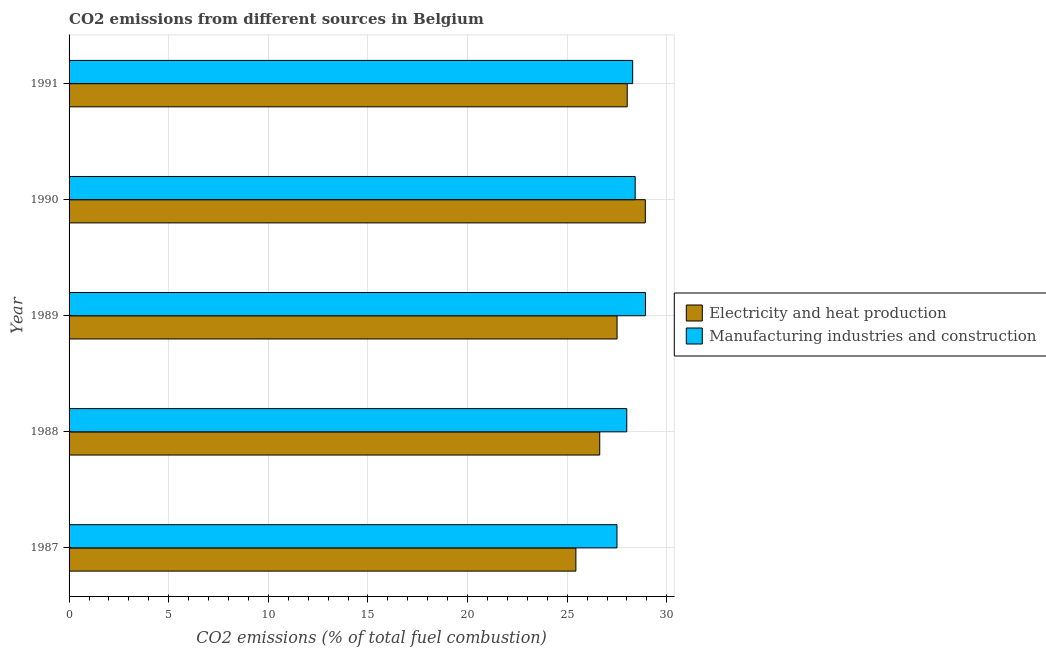How many groups of bars are there?
Keep it short and to the point. 5. Are the number of bars per tick equal to the number of legend labels?
Your response must be concise. Yes. Are the number of bars on each tick of the Y-axis equal?
Provide a succinct answer. Yes. How many bars are there on the 2nd tick from the top?
Give a very brief answer. 2. What is the co2 emissions due to manufacturing industries in 1991?
Ensure brevity in your answer.  28.29. Across all years, what is the maximum co2 emissions due to electricity and heat production?
Make the answer very short. 28.92. Across all years, what is the minimum co2 emissions due to manufacturing industries?
Your answer should be very brief. 27.5. In which year was the co2 emissions due to electricity and heat production maximum?
Your answer should be very brief. 1990. What is the total co2 emissions due to electricity and heat production in the graph?
Ensure brevity in your answer.  136.5. What is the difference between the co2 emissions due to electricity and heat production in 1990 and that in 1991?
Ensure brevity in your answer.  0.91. What is the difference between the co2 emissions due to manufacturing industries in 1987 and the co2 emissions due to electricity and heat production in 1989?
Offer a terse response. -0. What is the average co2 emissions due to manufacturing industries per year?
Your answer should be compact. 28.22. In the year 1988, what is the difference between the co2 emissions due to manufacturing industries and co2 emissions due to electricity and heat production?
Keep it short and to the point. 1.36. In how many years, is the co2 emissions due to manufacturing industries greater than 4 %?
Make the answer very short. 5. What is the ratio of the co2 emissions due to electricity and heat production in 1987 to that in 1991?
Keep it short and to the point. 0.91. Is the difference between the co2 emissions due to manufacturing industries in 1987 and 1990 greater than the difference between the co2 emissions due to electricity and heat production in 1987 and 1990?
Provide a succinct answer. Yes. What is the difference between the highest and the second highest co2 emissions due to manufacturing industries?
Offer a terse response. 0.52. What is the difference between the highest and the lowest co2 emissions due to electricity and heat production?
Ensure brevity in your answer.  3.49. What does the 2nd bar from the top in 1989 represents?
Offer a terse response. Electricity and heat production. What does the 1st bar from the bottom in 1991 represents?
Your answer should be compact. Electricity and heat production. How many bars are there?
Your answer should be compact. 10. Does the graph contain any zero values?
Offer a terse response. No. Where does the legend appear in the graph?
Keep it short and to the point. Center right. How many legend labels are there?
Provide a short and direct response. 2. How are the legend labels stacked?
Provide a short and direct response. Vertical. What is the title of the graph?
Provide a succinct answer. CO2 emissions from different sources in Belgium. Does "% of gross capital formation" appear as one of the legend labels in the graph?
Offer a very short reply. No. What is the label or title of the X-axis?
Keep it short and to the point. CO2 emissions (% of total fuel combustion). What is the CO2 emissions (% of total fuel combustion) of Electricity and heat production in 1987?
Keep it short and to the point. 25.44. What is the CO2 emissions (% of total fuel combustion) in Manufacturing industries and construction in 1987?
Offer a terse response. 27.5. What is the CO2 emissions (% of total fuel combustion) of Electricity and heat production in 1988?
Provide a succinct answer. 26.63. What is the CO2 emissions (% of total fuel combustion) in Manufacturing industries and construction in 1988?
Your response must be concise. 27.99. What is the CO2 emissions (% of total fuel combustion) in Electricity and heat production in 1989?
Give a very brief answer. 27.5. What is the CO2 emissions (% of total fuel combustion) in Manufacturing industries and construction in 1989?
Give a very brief answer. 28.93. What is the CO2 emissions (% of total fuel combustion) in Electricity and heat production in 1990?
Provide a short and direct response. 28.92. What is the CO2 emissions (% of total fuel combustion) in Manufacturing industries and construction in 1990?
Your answer should be compact. 28.41. What is the CO2 emissions (% of total fuel combustion) in Electricity and heat production in 1991?
Give a very brief answer. 28.01. What is the CO2 emissions (% of total fuel combustion) in Manufacturing industries and construction in 1991?
Offer a terse response. 28.29. Across all years, what is the maximum CO2 emissions (% of total fuel combustion) of Electricity and heat production?
Give a very brief answer. 28.92. Across all years, what is the maximum CO2 emissions (% of total fuel combustion) in Manufacturing industries and construction?
Your answer should be compact. 28.93. Across all years, what is the minimum CO2 emissions (% of total fuel combustion) in Electricity and heat production?
Give a very brief answer. 25.44. Across all years, what is the minimum CO2 emissions (% of total fuel combustion) in Manufacturing industries and construction?
Ensure brevity in your answer.  27.5. What is the total CO2 emissions (% of total fuel combustion) of Electricity and heat production in the graph?
Your response must be concise. 136.5. What is the total CO2 emissions (% of total fuel combustion) in Manufacturing industries and construction in the graph?
Provide a short and direct response. 141.11. What is the difference between the CO2 emissions (% of total fuel combustion) in Electricity and heat production in 1987 and that in 1988?
Offer a terse response. -1.2. What is the difference between the CO2 emissions (% of total fuel combustion) in Manufacturing industries and construction in 1987 and that in 1988?
Offer a terse response. -0.49. What is the difference between the CO2 emissions (% of total fuel combustion) in Electricity and heat production in 1987 and that in 1989?
Your answer should be compact. -2.07. What is the difference between the CO2 emissions (% of total fuel combustion) of Manufacturing industries and construction in 1987 and that in 1989?
Ensure brevity in your answer.  -1.43. What is the difference between the CO2 emissions (% of total fuel combustion) in Electricity and heat production in 1987 and that in 1990?
Your answer should be very brief. -3.49. What is the difference between the CO2 emissions (% of total fuel combustion) in Manufacturing industries and construction in 1987 and that in 1990?
Your answer should be compact. -0.91. What is the difference between the CO2 emissions (% of total fuel combustion) in Electricity and heat production in 1987 and that in 1991?
Provide a succinct answer. -2.58. What is the difference between the CO2 emissions (% of total fuel combustion) in Manufacturing industries and construction in 1987 and that in 1991?
Make the answer very short. -0.79. What is the difference between the CO2 emissions (% of total fuel combustion) of Electricity and heat production in 1988 and that in 1989?
Your response must be concise. -0.87. What is the difference between the CO2 emissions (% of total fuel combustion) in Manufacturing industries and construction in 1988 and that in 1989?
Provide a succinct answer. -0.94. What is the difference between the CO2 emissions (% of total fuel combustion) in Electricity and heat production in 1988 and that in 1990?
Provide a short and direct response. -2.29. What is the difference between the CO2 emissions (% of total fuel combustion) of Manufacturing industries and construction in 1988 and that in 1990?
Your answer should be very brief. -0.42. What is the difference between the CO2 emissions (% of total fuel combustion) of Electricity and heat production in 1988 and that in 1991?
Offer a very short reply. -1.38. What is the difference between the CO2 emissions (% of total fuel combustion) in Manufacturing industries and construction in 1988 and that in 1991?
Offer a very short reply. -0.3. What is the difference between the CO2 emissions (% of total fuel combustion) of Electricity and heat production in 1989 and that in 1990?
Your answer should be compact. -1.42. What is the difference between the CO2 emissions (% of total fuel combustion) in Manufacturing industries and construction in 1989 and that in 1990?
Offer a very short reply. 0.52. What is the difference between the CO2 emissions (% of total fuel combustion) in Electricity and heat production in 1989 and that in 1991?
Provide a short and direct response. -0.51. What is the difference between the CO2 emissions (% of total fuel combustion) in Manufacturing industries and construction in 1989 and that in 1991?
Keep it short and to the point. 0.64. What is the difference between the CO2 emissions (% of total fuel combustion) in Electricity and heat production in 1990 and that in 1991?
Your answer should be very brief. 0.91. What is the difference between the CO2 emissions (% of total fuel combustion) in Manufacturing industries and construction in 1990 and that in 1991?
Provide a short and direct response. 0.13. What is the difference between the CO2 emissions (% of total fuel combustion) of Electricity and heat production in 1987 and the CO2 emissions (% of total fuel combustion) of Manufacturing industries and construction in 1988?
Your answer should be compact. -2.55. What is the difference between the CO2 emissions (% of total fuel combustion) in Electricity and heat production in 1987 and the CO2 emissions (% of total fuel combustion) in Manufacturing industries and construction in 1989?
Provide a succinct answer. -3.49. What is the difference between the CO2 emissions (% of total fuel combustion) in Electricity and heat production in 1987 and the CO2 emissions (% of total fuel combustion) in Manufacturing industries and construction in 1990?
Keep it short and to the point. -2.98. What is the difference between the CO2 emissions (% of total fuel combustion) of Electricity and heat production in 1987 and the CO2 emissions (% of total fuel combustion) of Manufacturing industries and construction in 1991?
Your answer should be very brief. -2.85. What is the difference between the CO2 emissions (% of total fuel combustion) of Electricity and heat production in 1988 and the CO2 emissions (% of total fuel combustion) of Manufacturing industries and construction in 1989?
Ensure brevity in your answer.  -2.3. What is the difference between the CO2 emissions (% of total fuel combustion) in Electricity and heat production in 1988 and the CO2 emissions (% of total fuel combustion) in Manufacturing industries and construction in 1990?
Your answer should be very brief. -1.78. What is the difference between the CO2 emissions (% of total fuel combustion) of Electricity and heat production in 1988 and the CO2 emissions (% of total fuel combustion) of Manufacturing industries and construction in 1991?
Your answer should be compact. -1.65. What is the difference between the CO2 emissions (% of total fuel combustion) of Electricity and heat production in 1989 and the CO2 emissions (% of total fuel combustion) of Manufacturing industries and construction in 1990?
Provide a short and direct response. -0.91. What is the difference between the CO2 emissions (% of total fuel combustion) in Electricity and heat production in 1989 and the CO2 emissions (% of total fuel combustion) in Manufacturing industries and construction in 1991?
Keep it short and to the point. -0.78. What is the difference between the CO2 emissions (% of total fuel combustion) in Electricity and heat production in 1990 and the CO2 emissions (% of total fuel combustion) in Manufacturing industries and construction in 1991?
Keep it short and to the point. 0.64. What is the average CO2 emissions (% of total fuel combustion) of Electricity and heat production per year?
Offer a very short reply. 27.3. What is the average CO2 emissions (% of total fuel combustion) in Manufacturing industries and construction per year?
Your answer should be compact. 28.22. In the year 1987, what is the difference between the CO2 emissions (% of total fuel combustion) in Electricity and heat production and CO2 emissions (% of total fuel combustion) in Manufacturing industries and construction?
Provide a short and direct response. -2.06. In the year 1988, what is the difference between the CO2 emissions (% of total fuel combustion) of Electricity and heat production and CO2 emissions (% of total fuel combustion) of Manufacturing industries and construction?
Your answer should be very brief. -1.36. In the year 1989, what is the difference between the CO2 emissions (% of total fuel combustion) of Electricity and heat production and CO2 emissions (% of total fuel combustion) of Manufacturing industries and construction?
Offer a terse response. -1.43. In the year 1990, what is the difference between the CO2 emissions (% of total fuel combustion) in Electricity and heat production and CO2 emissions (% of total fuel combustion) in Manufacturing industries and construction?
Provide a short and direct response. 0.51. In the year 1991, what is the difference between the CO2 emissions (% of total fuel combustion) in Electricity and heat production and CO2 emissions (% of total fuel combustion) in Manufacturing industries and construction?
Provide a short and direct response. -0.27. What is the ratio of the CO2 emissions (% of total fuel combustion) of Electricity and heat production in 1987 to that in 1988?
Your answer should be compact. 0.96. What is the ratio of the CO2 emissions (% of total fuel combustion) in Manufacturing industries and construction in 1987 to that in 1988?
Give a very brief answer. 0.98. What is the ratio of the CO2 emissions (% of total fuel combustion) in Electricity and heat production in 1987 to that in 1989?
Offer a very short reply. 0.92. What is the ratio of the CO2 emissions (% of total fuel combustion) in Manufacturing industries and construction in 1987 to that in 1989?
Your answer should be very brief. 0.95. What is the ratio of the CO2 emissions (% of total fuel combustion) in Electricity and heat production in 1987 to that in 1990?
Ensure brevity in your answer.  0.88. What is the ratio of the CO2 emissions (% of total fuel combustion) of Manufacturing industries and construction in 1987 to that in 1990?
Your answer should be very brief. 0.97. What is the ratio of the CO2 emissions (% of total fuel combustion) in Electricity and heat production in 1987 to that in 1991?
Your answer should be very brief. 0.91. What is the ratio of the CO2 emissions (% of total fuel combustion) in Manufacturing industries and construction in 1987 to that in 1991?
Give a very brief answer. 0.97. What is the ratio of the CO2 emissions (% of total fuel combustion) in Electricity and heat production in 1988 to that in 1989?
Your answer should be compact. 0.97. What is the ratio of the CO2 emissions (% of total fuel combustion) of Manufacturing industries and construction in 1988 to that in 1989?
Ensure brevity in your answer.  0.97. What is the ratio of the CO2 emissions (% of total fuel combustion) of Electricity and heat production in 1988 to that in 1990?
Provide a succinct answer. 0.92. What is the ratio of the CO2 emissions (% of total fuel combustion) in Manufacturing industries and construction in 1988 to that in 1990?
Give a very brief answer. 0.99. What is the ratio of the CO2 emissions (% of total fuel combustion) of Electricity and heat production in 1988 to that in 1991?
Provide a succinct answer. 0.95. What is the ratio of the CO2 emissions (% of total fuel combustion) of Manufacturing industries and construction in 1988 to that in 1991?
Your response must be concise. 0.99. What is the ratio of the CO2 emissions (% of total fuel combustion) of Electricity and heat production in 1989 to that in 1990?
Your answer should be very brief. 0.95. What is the ratio of the CO2 emissions (% of total fuel combustion) of Manufacturing industries and construction in 1989 to that in 1990?
Your answer should be compact. 1.02. What is the ratio of the CO2 emissions (% of total fuel combustion) in Electricity and heat production in 1989 to that in 1991?
Make the answer very short. 0.98. What is the ratio of the CO2 emissions (% of total fuel combustion) in Manufacturing industries and construction in 1989 to that in 1991?
Provide a short and direct response. 1.02. What is the ratio of the CO2 emissions (% of total fuel combustion) in Electricity and heat production in 1990 to that in 1991?
Keep it short and to the point. 1.03. What is the difference between the highest and the second highest CO2 emissions (% of total fuel combustion) of Electricity and heat production?
Give a very brief answer. 0.91. What is the difference between the highest and the second highest CO2 emissions (% of total fuel combustion) in Manufacturing industries and construction?
Make the answer very short. 0.52. What is the difference between the highest and the lowest CO2 emissions (% of total fuel combustion) of Electricity and heat production?
Offer a very short reply. 3.49. What is the difference between the highest and the lowest CO2 emissions (% of total fuel combustion) in Manufacturing industries and construction?
Give a very brief answer. 1.43. 